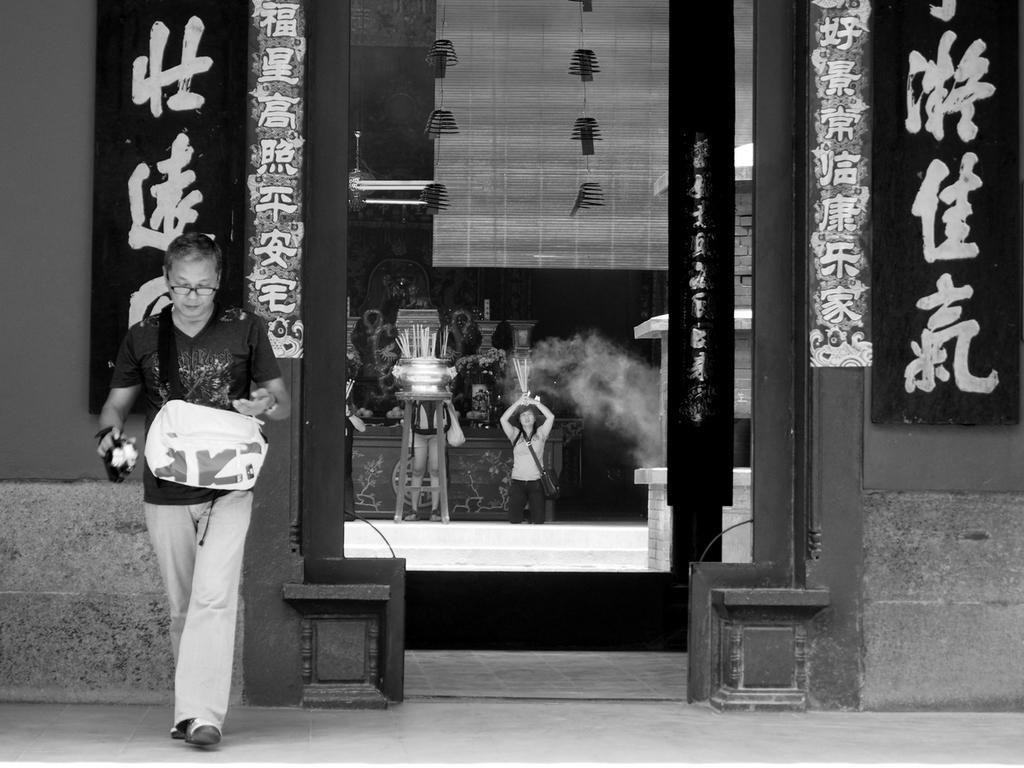Could you give a brief overview of what you see in this image? This is a black and white pic. On the left a person is walking on the floor and carrying a bag on his shoulder and there is an object in his hand. In the background there are hoardings on the wall,few persons are standing and there is an object on a stool,wall and other objects and a person among them is holding an object in the hands and carrying a bag on the shoulder. 